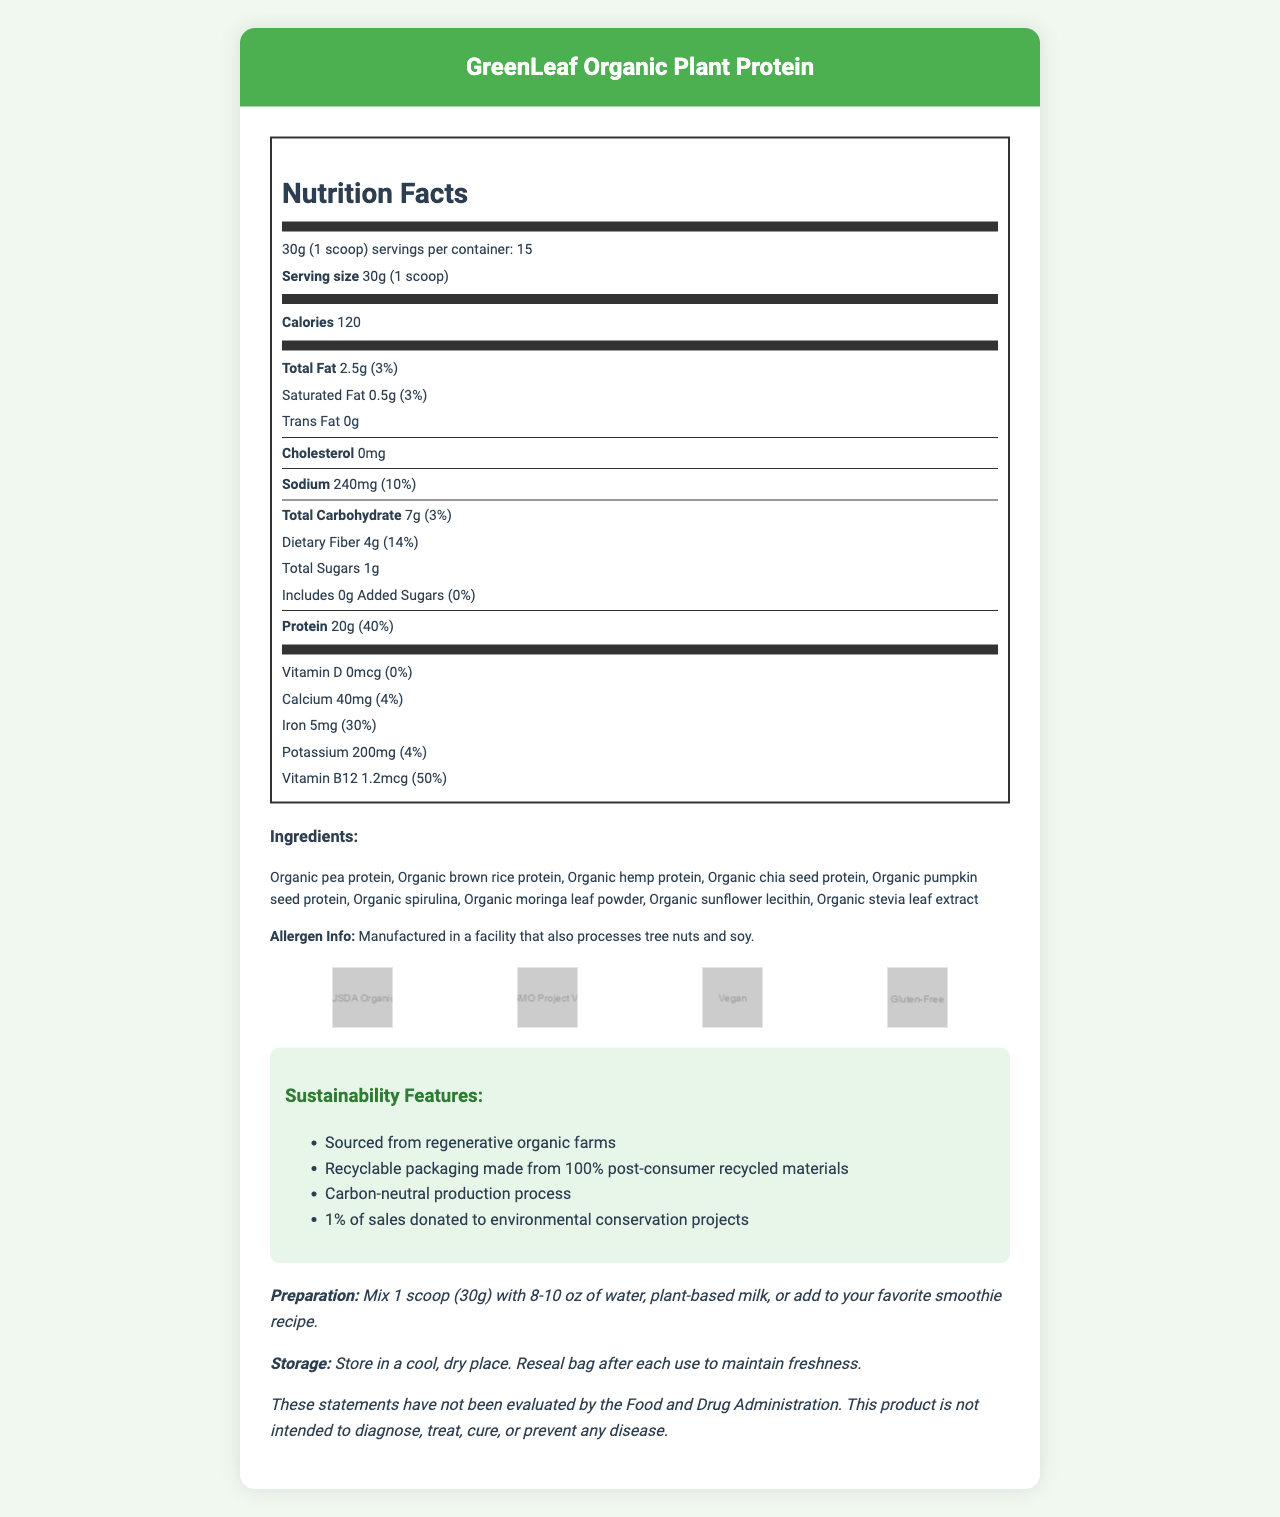what is the serving size? The serving size is explicitly mentioned in the document as "30g (1 scoop)".
Answer: 30g (1 scoop) how many servings are in the container? The document states that there are 15 servings per container.
Answer: 15 how many grams of protein are in one serving? The document indicates that each serving contains 20g of protein.
Answer: 20g what percentage of daily value for iron does this product provide per serving? The document lists the iron content as 5mg per serving, which is 30% of the daily value.
Answer: 30% are there any added sugars in this product? The document clearly mentions that there are 0g of added sugars, which is 0% of the daily value.
Answer: No what is the sodium content per serving? The sodium content per serving is explicitly listed as 240mg in the document.
Answer: 240mg which of the following ingredients is not part of the product? A. Organic pea protein B. Organic quinoa protein C. Organic chia seed protein The document lists Organic pea protein and Organic chia seed protein but not Organic quinoa protein.
Answer: B how many grams of dietary fiber are in one serving? The document indicates that each serving contains 4g of dietary fiber.
Answer: 4g which vitamin has the highest daily value percentage per serving? A. Vitamin D B. Calcium C. Iron D. Vitamin B12 Vitamin B12 has the highest daily value percentage per serving at 50%, as stated in the document.
Answer: D is the product carbon-neutral? The sustainability features section of the document mentions that the product has a carbon-neutral production process.
Answer: Yes summarize the main idea of this document. The document is comprehensive, covering various aspects of the product, including its nutritional content, ingredient list, allergen information, and certifications. It highlights the product's commitment to sustainability through various features such as sourcing from regenerative organic farms and carbon-neutral production.
Answer: The document provides nutritional information, ingredient details, certifications, sustainability features, and preparation and storage instructions for GreenLeaf Organic Plant Protein. Notable points include its high protein and dietary fiber content, lack of added sugars, and several certifications such as USDA Organic and Gluten-Free. The product supports sustainable practices and has a carbon-neutral production process. what is the total fat content per serving? The document lists the total fat content per serving as 2.5g.
Answer: 2.5g what certifications does this product have? The document includes a section for certifications, which lists USDA Organic, Non-GMO Project Verified, Vegan, and Gluten-Free.
Answer: USDA Organic, Non-GMO Project Verified, Vegan, Gluten-Free what types of protein are included in the ingredients? The ingredients section of the document lists multiple sources of protein including Organic pea protein, Organic brown rice protein, Organic hemp protein, Organic chia seed protein, and Organic pumpkin seed protein.
Answer: Organic pea protein, Organic brown rice protein, Organic hemp protein, Organic chia seed protein, Organic pumpkin seed protein are there any allergen warnings for this product? The document includes an allergen warning that mentions the product is manufactured in a facility that also processes tree nuts and soy.
Answer: Yes how is the packaging sustainability feature described? The sustainability features section mentions that the packaging is made from 100% post-consumer recycled materials.
Answer: Recyclable packaging made from 100% post-consumer recycled materials what is the preparation instruction for one serving? The preparation instructions in the document suggest mixing one scoop (30g) with 8-10 oz of liquid or adding it to a smoothie.
Answer: Mix 1 scoop (30g) with 8-10 oz of water, plant-based milk, or add to your favorite smoothie recipe does the product contain any cholesterol? The document explicitly states that the product contains 0mg of cholesterol.
Answer: No what is the company's commitment percentage towards environmental conservation projects? The sustainability features section states that 1% of sales is donated to environmental conservation projects.
Answer: 1% does the label mention anything about the product helping with weight loss? The document does not make any claims about weight loss.
Answer: Not enough information can this product be used by someone who is vegan? The document lists "Vegan" as one of the certifications for the product.
Answer: Yes 